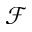Convert formula to latex. <formula><loc_0><loc_0><loc_500><loc_500>\mathcal { F }</formula> 